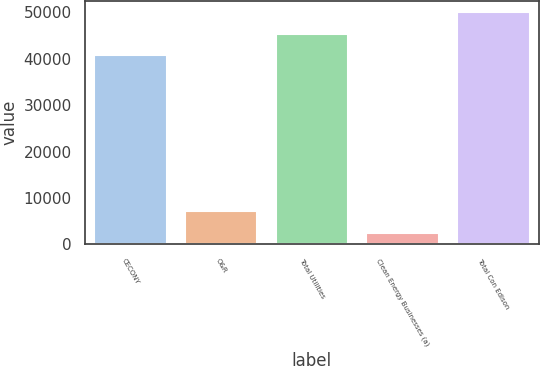Convert chart to OTSL. <chart><loc_0><loc_0><loc_500><loc_500><bar_chart><fcel>CECONY<fcel>O&R<fcel>Total Utilities<fcel>Clean Energy Businesses (a)<fcel>Total Con Edison<nl><fcel>40856<fcel>7121.4<fcel>45426.4<fcel>2551<fcel>49996.8<nl></chart> 